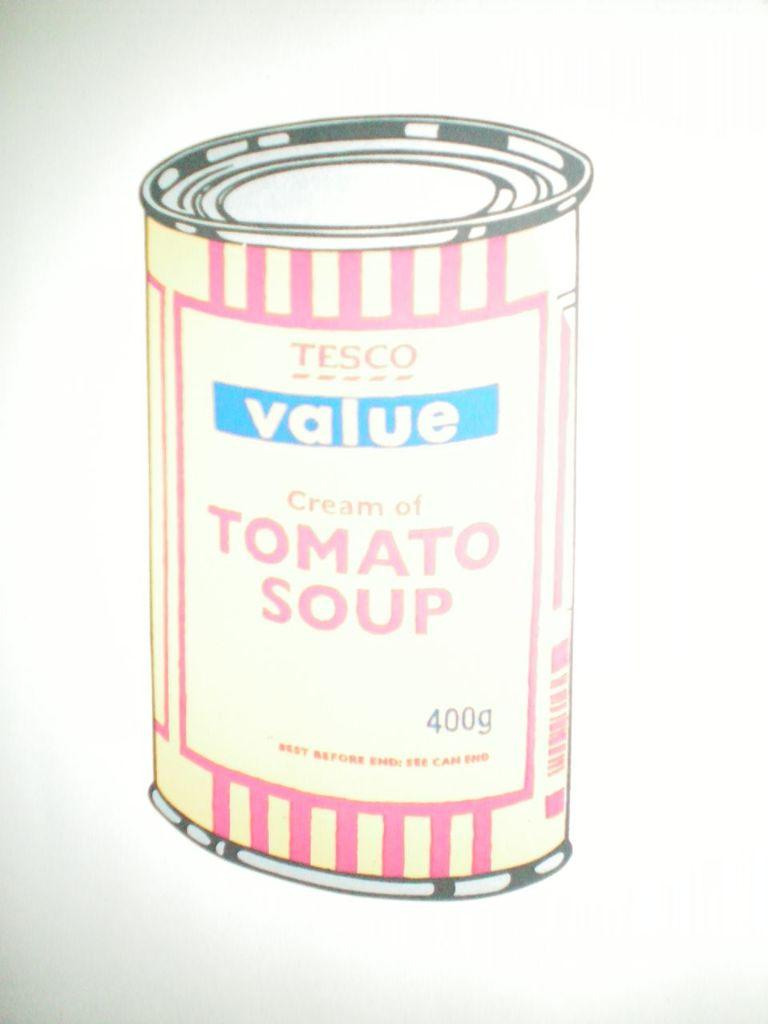<image>
Relay a brief, clear account of the picture shown. A can of Tesco cream of tomato soup. 